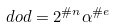<formula> <loc_0><loc_0><loc_500><loc_500>d o d = 2 ^ { \# n } \alpha ^ { \# e }</formula> 